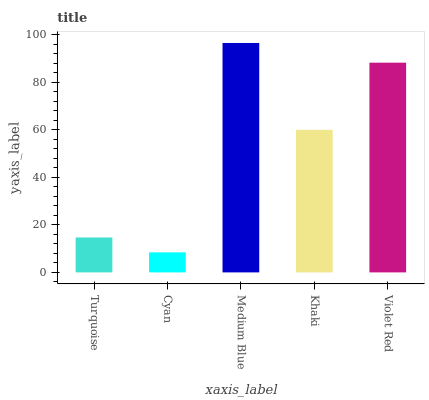Is Medium Blue the minimum?
Answer yes or no. No. Is Cyan the maximum?
Answer yes or no. No. Is Medium Blue greater than Cyan?
Answer yes or no. Yes. Is Cyan less than Medium Blue?
Answer yes or no. Yes. Is Cyan greater than Medium Blue?
Answer yes or no. No. Is Medium Blue less than Cyan?
Answer yes or no. No. Is Khaki the high median?
Answer yes or no. Yes. Is Khaki the low median?
Answer yes or no. Yes. Is Turquoise the high median?
Answer yes or no. No. Is Turquoise the low median?
Answer yes or no. No. 